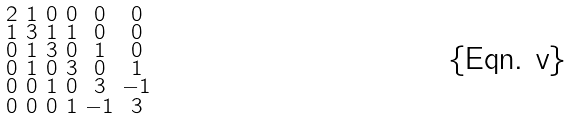<formula> <loc_0><loc_0><loc_500><loc_500>\begin{smallmatrix} 2 & 1 & 0 & 0 & 0 & 0 \\ 1 & 3 & 1 & 1 & 0 & 0 \\ 0 & 1 & 3 & 0 & 1 & 0 \\ 0 & 1 & 0 & 3 & 0 & 1 \\ 0 & 0 & 1 & 0 & 3 & - 1 \\ 0 & 0 & 0 & 1 & - 1 & 3 \end{smallmatrix}</formula> 